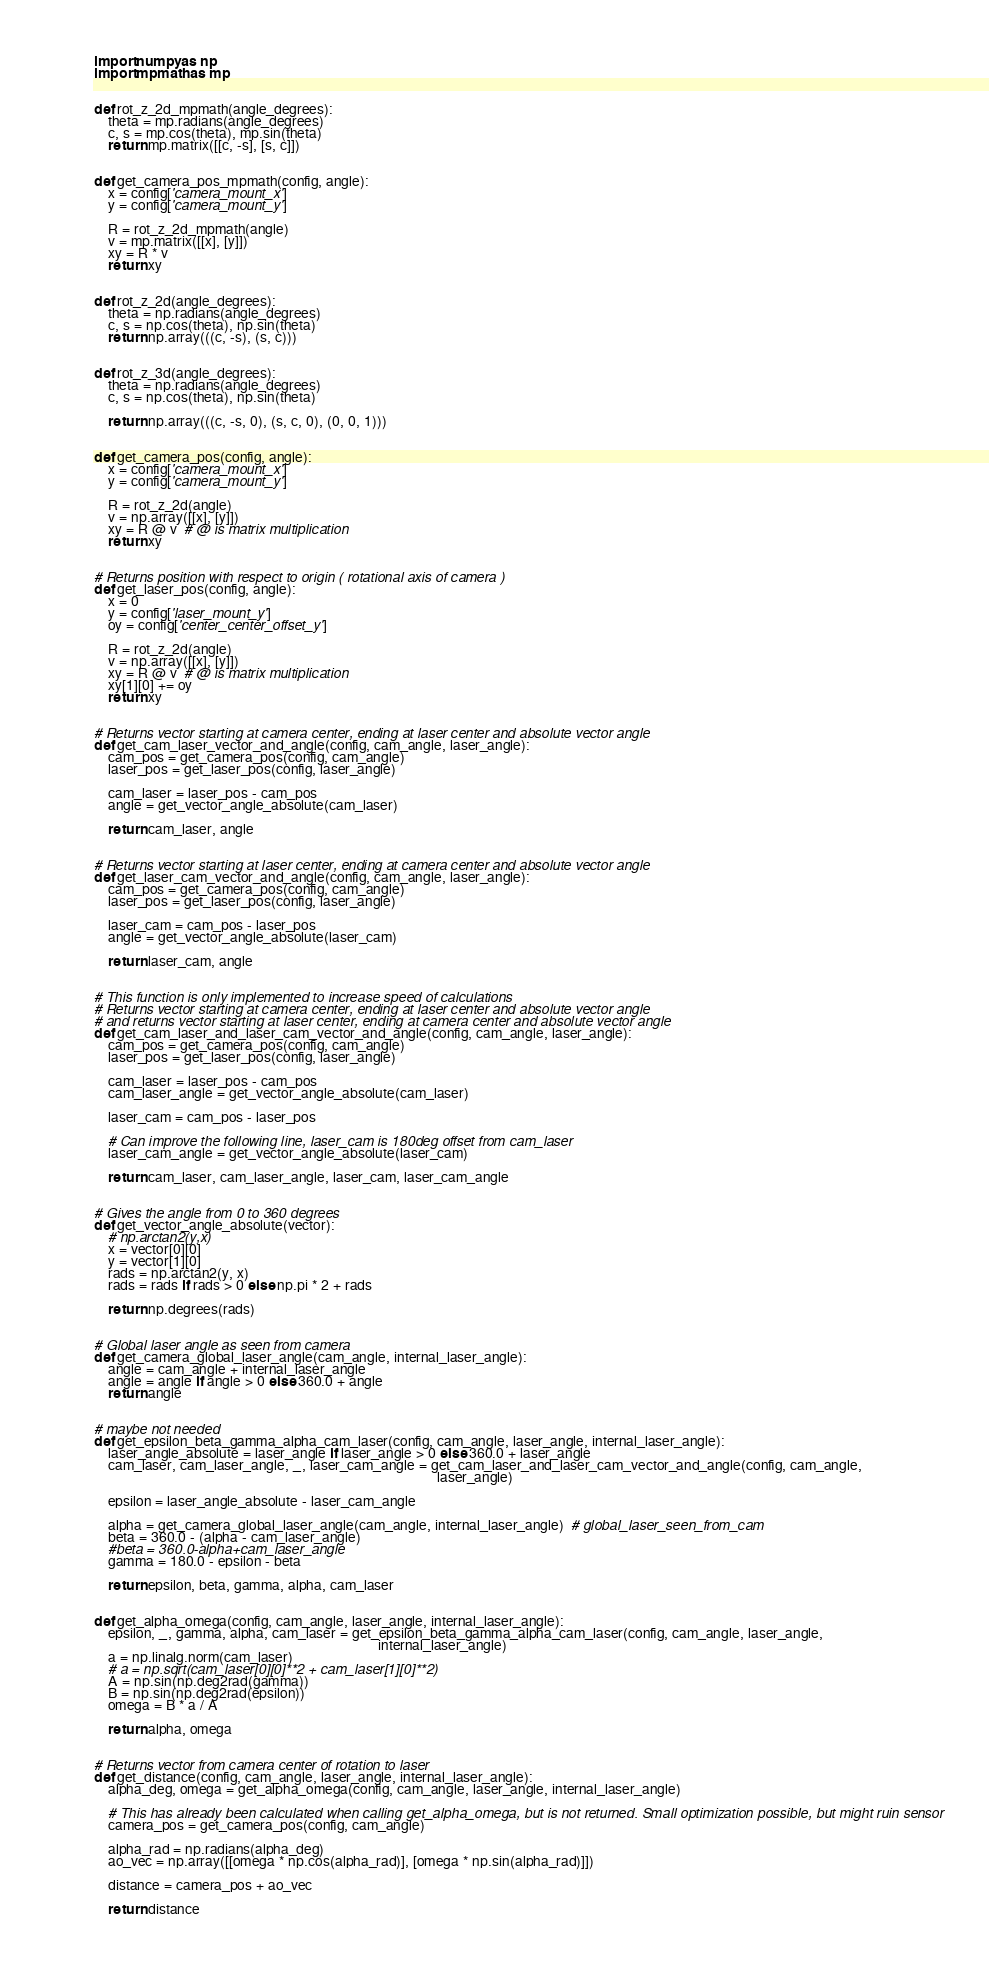<code> <loc_0><loc_0><loc_500><loc_500><_Python_>import numpy as np
import mpmath as mp


def rot_z_2d_mpmath(angle_degrees):
    theta = mp.radians(angle_degrees)
    c, s = mp.cos(theta), mp.sin(theta)
    return mp.matrix([[c, -s], [s, c]])


def get_camera_pos_mpmath(config, angle):
    x = config['camera_mount_x']
    y = config['camera_mount_y']

    R = rot_z_2d_mpmath(angle)
    v = mp.matrix([[x], [y]])
    xy = R * v
    return xy


def rot_z_2d(angle_degrees):
    theta = np.radians(angle_degrees)
    c, s = np.cos(theta), np.sin(theta)
    return np.array(((c, -s), (s, c)))


def rot_z_3d(angle_degrees):
    theta = np.radians(angle_degrees)
    c, s = np.cos(theta), np.sin(theta)

    return np.array(((c, -s, 0), (s, c, 0), (0, 0, 1)))


def get_camera_pos(config, angle):
    x = config['camera_mount_x']
    y = config['camera_mount_y']

    R = rot_z_2d(angle)
    v = np.array([[x], [y]])
    xy = R @ v  # @ is matrix multiplication
    return xy


# Returns position with respect to origin ( rotational axis of camera )
def get_laser_pos(config, angle):
    x = 0
    y = config['laser_mount_y']
    oy = config['center_center_offset_y']

    R = rot_z_2d(angle)
    v = np.array([[x], [y]])
    xy = R @ v  # @ is matrix multiplication
    xy[1][0] += oy
    return xy


# Returns vector starting at camera center, ending at laser center and absolute vector angle
def get_cam_laser_vector_and_angle(config, cam_angle, laser_angle):
    cam_pos = get_camera_pos(config, cam_angle)
    laser_pos = get_laser_pos(config, laser_angle)

    cam_laser = laser_pos - cam_pos
    angle = get_vector_angle_absolute(cam_laser)

    return cam_laser, angle


# Returns vector starting at laser center, ending at camera center and absolute vector angle
def get_laser_cam_vector_and_angle(config, cam_angle, laser_angle):
    cam_pos = get_camera_pos(config, cam_angle)
    laser_pos = get_laser_pos(config, laser_angle)

    laser_cam = cam_pos - laser_pos
    angle = get_vector_angle_absolute(laser_cam)

    return laser_cam, angle


# This function is only implemented to increase speed of calculations
# Returns vector starting at camera center, ending at laser center and absolute vector angle
# and returns vector starting at laser center, ending at camera center and absolute vector angle
def get_cam_laser_and_laser_cam_vector_and_angle(config, cam_angle, laser_angle):
    cam_pos = get_camera_pos(config, cam_angle)
    laser_pos = get_laser_pos(config, laser_angle)

    cam_laser = laser_pos - cam_pos
    cam_laser_angle = get_vector_angle_absolute(cam_laser)

    laser_cam = cam_pos - laser_pos

    # Can improve the following line, laser_cam is 180deg offset from cam_laser
    laser_cam_angle = get_vector_angle_absolute(laser_cam)

    return cam_laser, cam_laser_angle, laser_cam, laser_cam_angle


# Gives the angle from 0 to 360 degrees
def get_vector_angle_absolute(vector):
    # np.arctan2(y,x)
    x = vector[0][0]
    y = vector[1][0]
    rads = np.arctan2(y, x)
    rads = rads if rads > 0 else np.pi * 2 + rads

    return np.degrees(rads)


# Global laser angle as seen from camera
def get_camera_global_laser_angle(cam_angle, internal_laser_angle):
    angle = cam_angle + internal_laser_angle
    angle = angle if angle > 0 else 360.0 + angle
    return angle


# maybe not needed
def get_epsilon_beta_gamma_alpha_cam_laser(config, cam_angle, laser_angle, internal_laser_angle):
    laser_angle_absolute = laser_angle if laser_angle > 0 else 360.0 + laser_angle
    cam_laser, cam_laser_angle, _, laser_cam_angle = get_cam_laser_and_laser_cam_vector_and_angle(config, cam_angle,
                                                                                                  laser_angle)

    epsilon = laser_angle_absolute - laser_cam_angle

    alpha = get_camera_global_laser_angle(cam_angle, internal_laser_angle)  # global_laser_seen_from_cam
    beta = 360.0 - (alpha - cam_laser_angle)
    #beta = 360.0-alpha+cam_laser_angle
    gamma = 180.0 - epsilon - beta

    return epsilon, beta, gamma, alpha, cam_laser


def get_alpha_omega(config, cam_angle, laser_angle, internal_laser_angle):
    epsilon, _, gamma, alpha, cam_laser = get_epsilon_beta_gamma_alpha_cam_laser(config, cam_angle, laser_angle,
                                                                                 internal_laser_angle)
    a = np.linalg.norm(cam_laser)
    # a = np.sqrt(cam_laser[0][0]**2 + cam_laser[1][0]**2)
    A = np.sin(np.deg2rad(gamma))
    B = np.sin(np.deg2rad(epsilon))
    omega = B * a / A

    return alpha, omega


# Returns vector from camera center of rotation to laser
def get_distance(config, cam_angle, laser_angle, internal_laser_angle):
    alpha_deg, omega = get_alpha_omega(config, cam_angle, laser_angle, internal_laser_angle)

    # This has already been calculated when calling get_alpha_omega, but is not returned. Small optimization possible, but might ruin sensor
    camera_pos = get_camera_pos(config, cam_angle)

    alpha_rad = np.radians(alpha_deg)
    ao_vec = np.array([[omega * np.cos(alpha_rad)], [omega * np.sin(alpha_rad)]])

    distance = camera_pos + ao_vec

    return distance
</code> 